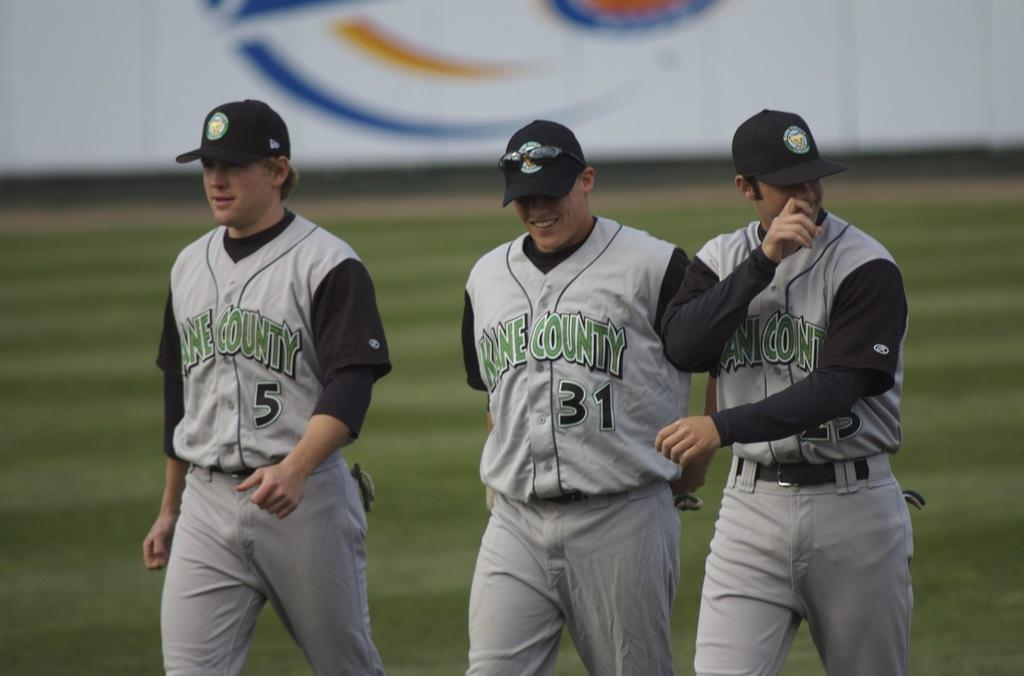<image>
Relay a brief, clear account of the picture shown. three baseball players wearing uniforms that says 'kane county' on them 